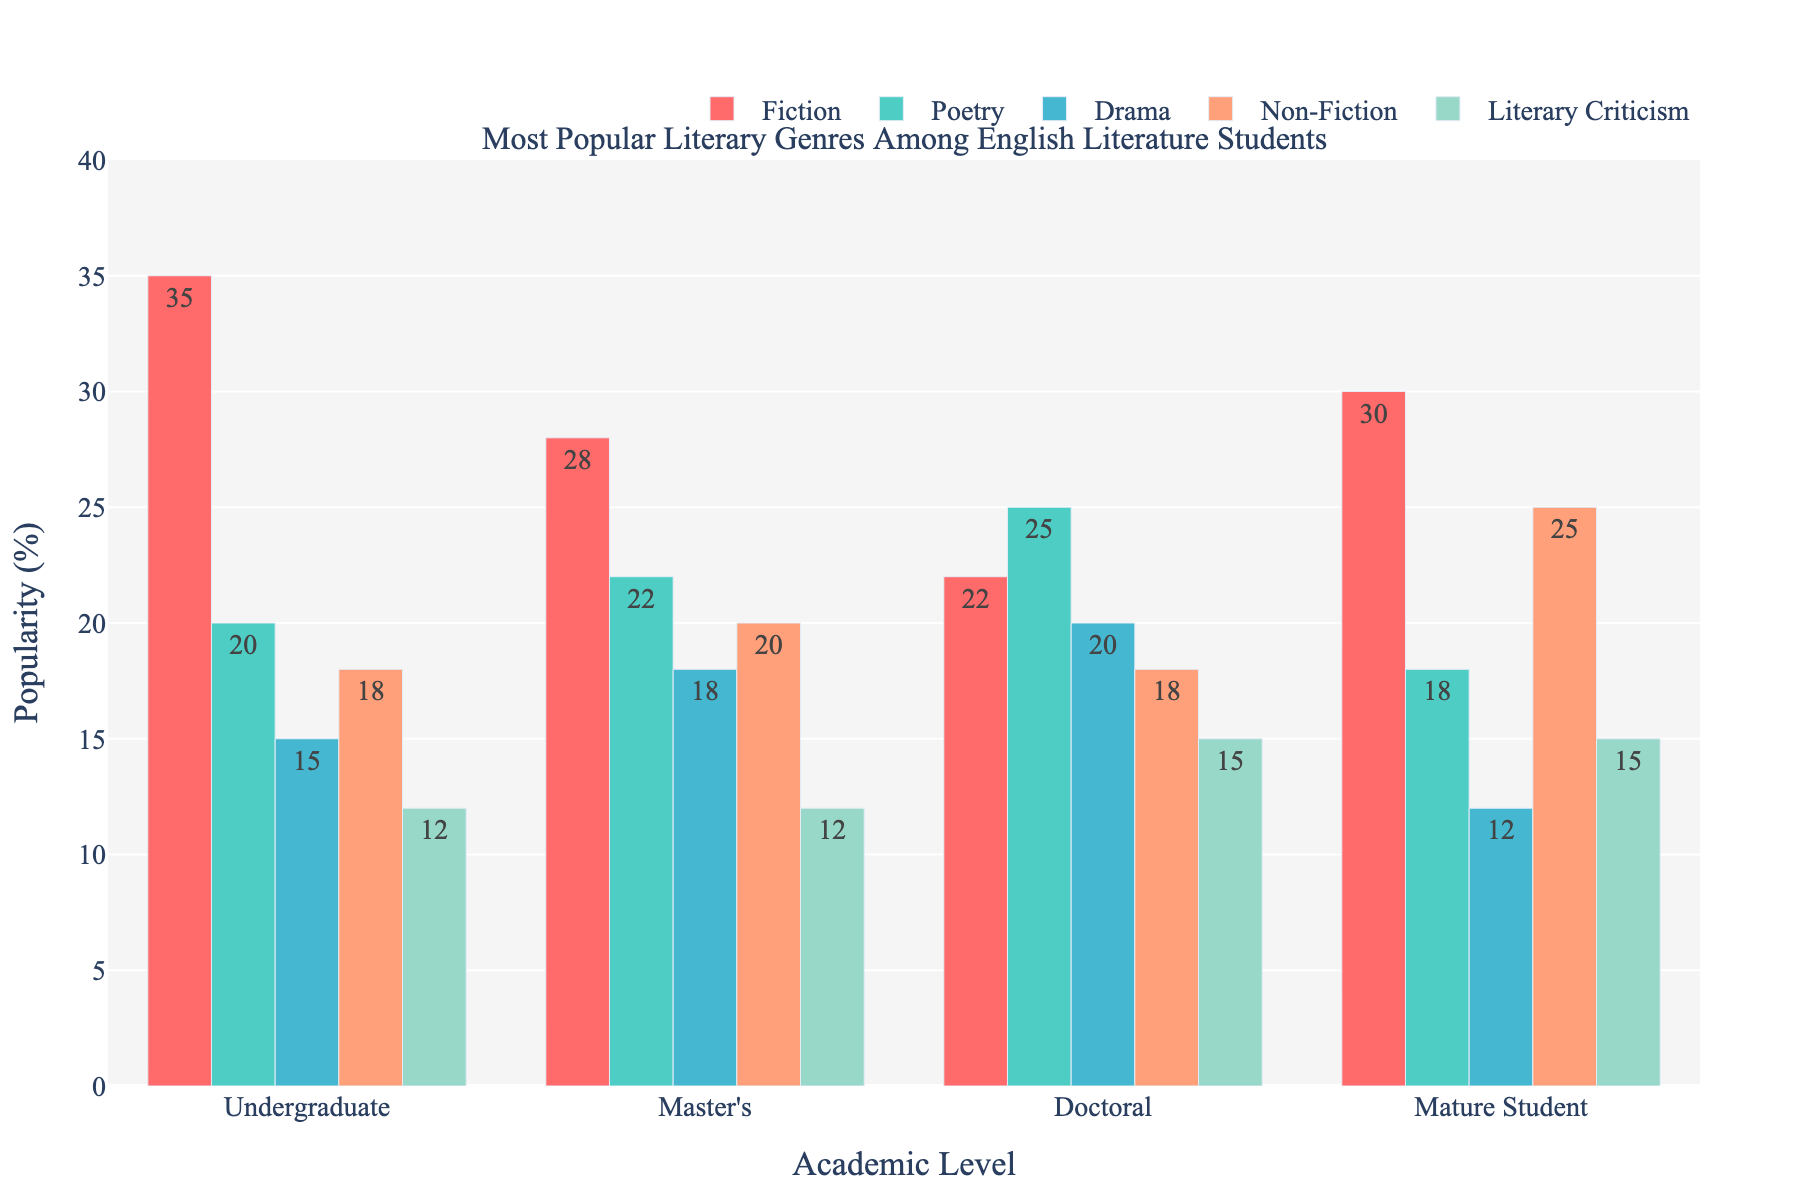what is the most popular literary genre among undergraduate students? To determine the most popular literary genre among undergraduate students, we look at the height of bars representing each genre for the undergraduate level. The bar representing Fiction is the highest.
Answer: Fiction Which genre has the highest popularity among doctoral students? We compare the heights of all bars corresponding to the doctoral level. The bar for Poetry is the tallest among them.
Answer: Poetry How does the preference for Non-Fiction differ between mature students and undergraduate students? To compare the preference for Non-Fiction between mature students and undergraduates, we look at the heights of the bars for both categories. For mature students, the Non-Fiction bar is higher (25%) than for undergraduates (18%).
Answer: Non-Fiction is more popular among mature students (25%) than undergraduates (18%) Which academic level shows the least interest in Drama? To find the academic level with the least interest in Drama, we look at the Drama bars and compare their heights. The Mature Student bar is the shortest at 12%.
Answer: Mature Student What is the average popularity of Non-Fiction across all academic levels? The Non-Fiction popularity percentages for all academic levels are 18, 20, 18, and 25. Summing these gives 81, and dividing by 4 provides the average: 81 / 4 = 20.25.
Answer: 20.25% Which genre sees the greatest increase in popularity when moving from undergraduate to doctoral levels? To determine the genre with the greatest increase, calculate the difference between undergraduate and doctoral levels for each genre:
  Fiction: 35 - 22 = 13
  Poetry: 25 - 20 = 5
  Drama: 20 - 15 = 5
  Non-Fiction: 18 - 18 = 0
  Literary Criticism: 15 - 12 = 3
The greatest difference is 13 for Fiction.
Answer: Fiction Is Fiction more popular among Master's or Doctoral students? Compare the heights of Fiction bars for Master's and Doctoral students. The bar for Master's is higher at 28% compared to Doctoral at 22%.
Answer: Master's What is the combined popularity of Poetry and Literary Criticism among undergraduate students? Add the percentages for Poetry (20%) and Literary Criticism (12%) among undergraduate students: 20 + 12 = 32.
Answer: 32% Which academic level has equal popularity for Fiction and Literary Criticism? Compare the heights of Fiction and Literary Criticism bars for each academic level. At the Master's level, both bars are at 12%.
Answer: Master's What is the range of popularity values for Drama across all academic levels? Determine the minimum and maximum values for Drama popularity: 12% (Mature Student) and 20% (Doctoral). The range is 20 - 12 = 8.
Answer: 8 